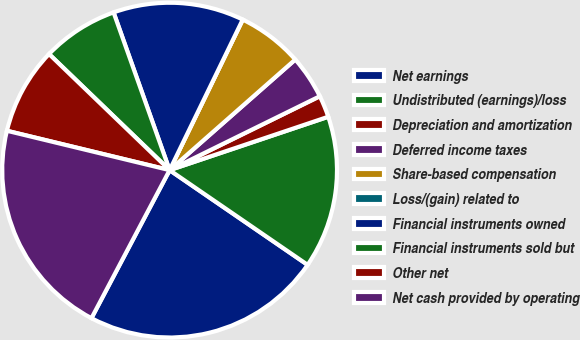<chart> <loc_0><loc_0><loc_500><loc_500><pie_chart><fcel>Net earnings<fcel>Undistributed (earnings)/loss<fcel>Depreciation and amortization<fcel>Deferred income taxes<fcel>Share-based compensation<fcel>Loss/(gain) related to<fcel>Financial instruments owned<fcel>Financial instruments sold but<fcel>Other net<fcel>Net cash provided by operating<nl><fcel>23.16%<fcel>14.74%<fcel>2.11%<fcel>4.21%<fcel>6.32%<fcel>0.0%<fcel>12.63%<fcel>7.37%<fcel>8.42%<fcel>21.05%<nl></chart> 